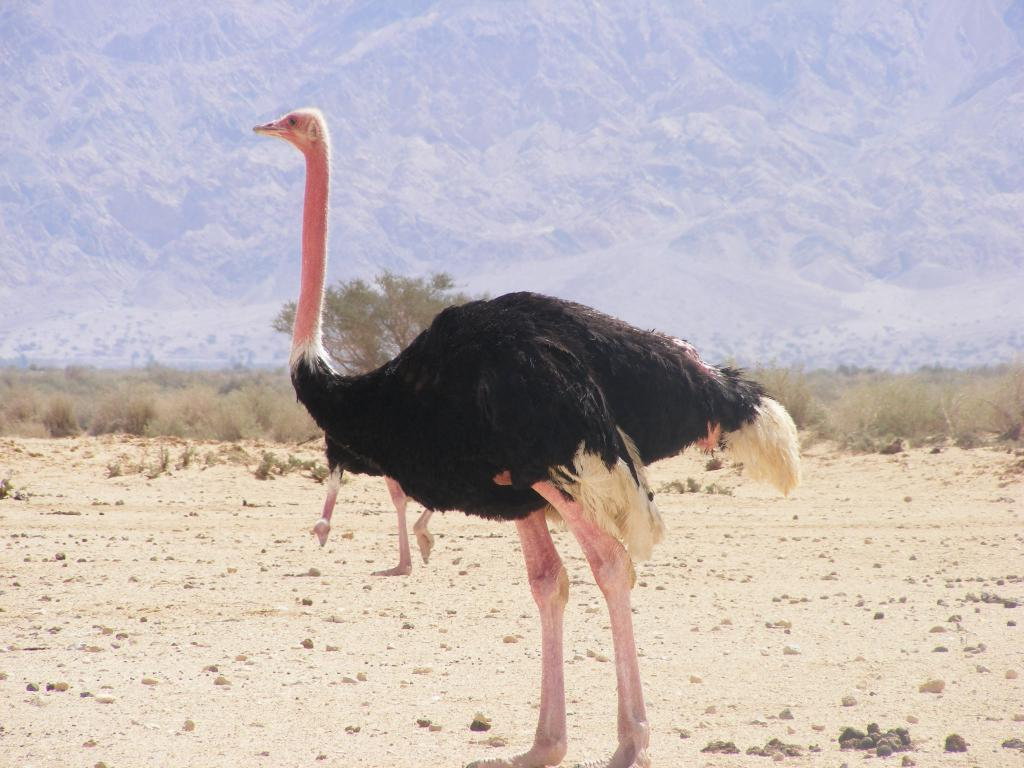What type of bird can be seen in the image? There is a black color bird in the image. Where is the bird located in relation to the image? The bird is in the front of the image. What can be seen in the background of the image? There is grass, a tree, and hills in the background of the image. How many baseballs can be seen on the tree in the image? There are no baseballs present in the image; it features a black color bird in the front and a tree, grass, and hills in the background. 